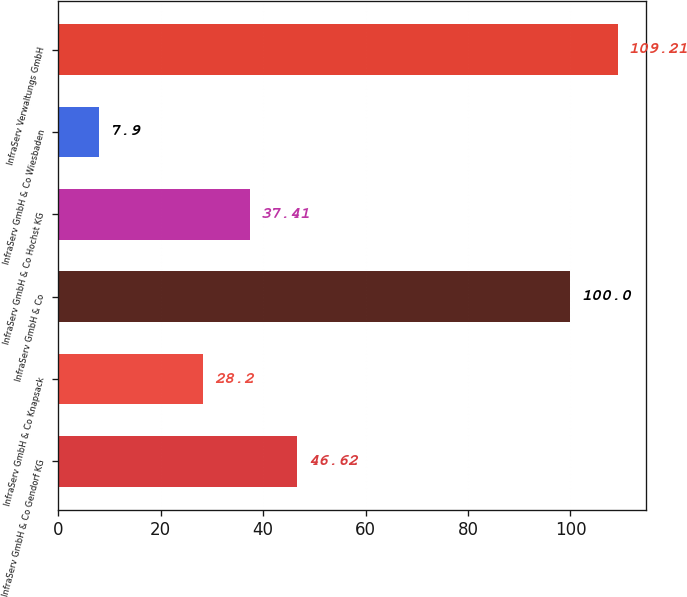Convert chart to OTSL. <chart><loc_0><loc_0><loc_500><loc_500><bar_chart><fcel>InfraServ GmbH & Co Gendorf KG<fcel>InfraServ GmbH & Co Knapsack<fcel>InfraServ GmbH & Co<fcel>InfraServ GmbH & Co Hochst KG<fcel>InfraServ GmbH & Co Wiesbaden<fcel>InfraServ Verwaltungs GmbH<nl><fcel>46.62<fcel>28.2<fcel>100<fcel>37.41<fcel>7.9<fcel>109.21<nl></chart> 